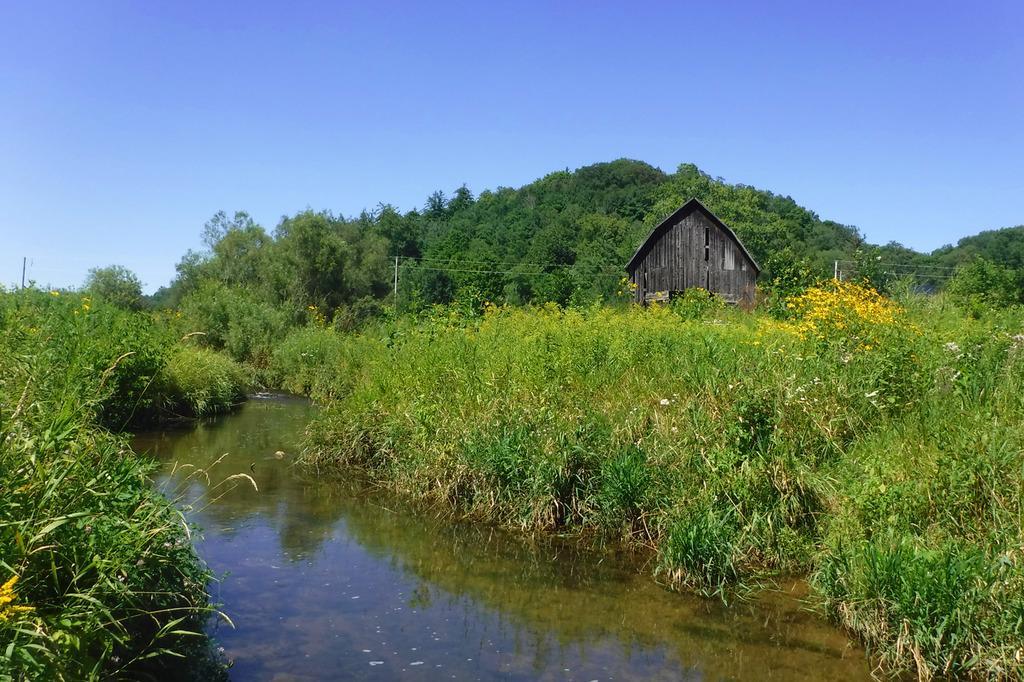Please provide a concise description of this image. In this image I can see trees and plants in green color, left I can see house in gray color. Background I can see sky in blue color. 